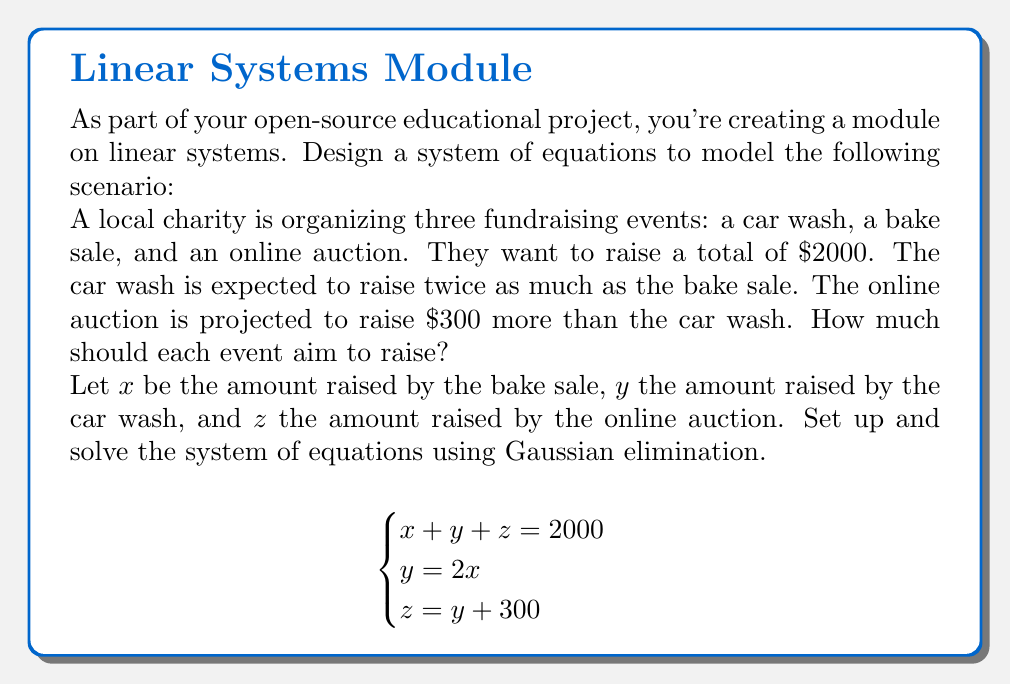Give your solution to this math problem. Let's solve this system using Gaussian elimination:

1) First, we'll rewrite the equations in standard form:
   $$\begin{cases}
   x + y + z = 2000 \quad (1)\\
   -2x + y = 0 \quad (2)\\
   -y + z = 300 \quad (3)
   \end{cases}$$

2) Now, we'll create an augmented matrix:
   $$\begin{bmatrix}
   1 & 1 & 1 & 2000 \\
   -2 & 1 & 0 & 0 \\
   0 & -1 & 1 & 300
   \end{bmatrix}$$

3) Add 2 times row 1 to row 2:
   $$\begin{bmatrix}
   1 & 1 & 1 & 2000 \\
   0 & 3 & 2 & 4000 \\
   0 & -1 & 1 & 300
   \end{bmatrix}$$

4) Add row 2 to row 3:
   $$\begin{bmatrix}
   1 & 1 & 1 & 2000 \\
   0 & 3 & 2 & 4000 \\
   0 & 2 & 3 & 4300
   \end{bmatrix}$$

5) Multiply row 2 by $\frac{2}{3}$ and subtract from row 3:
   $$\begin{bmatrix}
   1 & 1 & 1 & 2000 \\
   0 & 3 & 2 & 4000 \\
   0 & 0 & \frac{5}{3} & 1633.\overline{3}
   \end{bmatrix}$$

6) Now we have an upper triangular matrix. We can solve by back-substitution:
   
   From row 3: $z = 1633.\overline{3} \div \frac{5}{3} = 980$
   
   From row 2: $3y + 2(980) = 4000$, so $y = \frac{4000 - 1960}{3} = 680$
   
   From row 1: $x + 680 + 980 = 2000$, so $x = 340$

Therefore, the bake sale should aim to raise $340, the car wash $680, and the online auction $980.
Answer: Bake sale: $340, Car wash: $680, Online auction: $980 